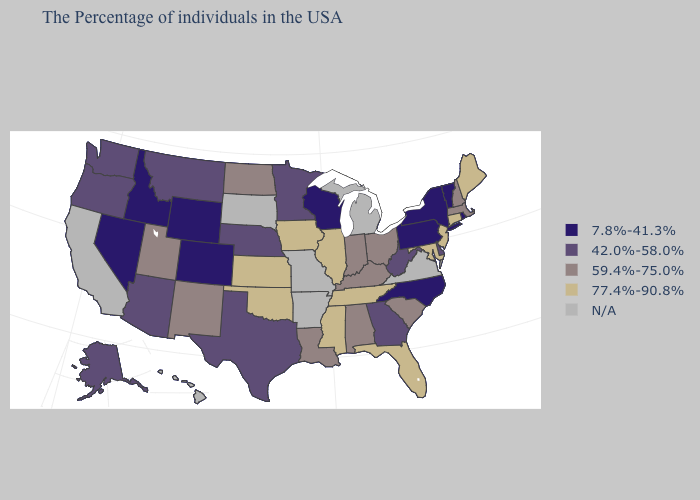What is the highest value in the South ?
Short answer required. 77.4%-90.8%. Name the states that have a value in the range 7.8%-41.3%?
Quick response, please. Rhode Island, Vermont, New York, Pennsylvania, North Carolina, Wisconsin, Wyoming, Colorado, Idaho, Nevada. Name the states that have a value in the range 7.8%-41.3%?
Short answer required. Rhode Island, Vermont, New York, Pennsylvania, North Carolina, Wisconsin, Wyoming, Colorado, Idaho, Nevada. What is the highest value in the Northeast ?
Concise answer only. 77.4%-90.8%. What is the value of North Carolina?
Keep it brief. 7.8%-41.3%. What is the value of South Carolina?
Quick response, please. 59.4%-75.0%. Name the states that have a value in the range 42.0%-58.0%?
Answer briefly. Delaware, West Virginia, Georgia, Minnesota, Nebraska, Texas, Montana, Arizona, Washington, Oregon, Alaska. Does the first symbol in the legend represent the smallest category?
Quick response, please. Yes. Which states have the highest value in the USA?
Quick response, please. Maine, Connecticut, New Jersey, Maryland, Florida, Tennessee, Illinois, Mississippi, Iowa, Kansas, Oklahoma. What is the value of Nebraska?
Concise answer only. 42.0%-58.0%. Does the first symbol in the legend represent the smallest category?
Short answer required. Yes. What is the highest value in the USA?
Answer briefly. 77.4%-90.8%. Name the states that have a value in the range 59.4%-75.0%?
Give a very brief answer. Massachusetts, New Hampshire, South Carolina, Ohio, Kentucky, Indiana, Alabama, Louisiana, North Dakota, New Mexico, Utah. What is the value of Mississippi?
Give a very brief answer. 77.4%-90.8%. 